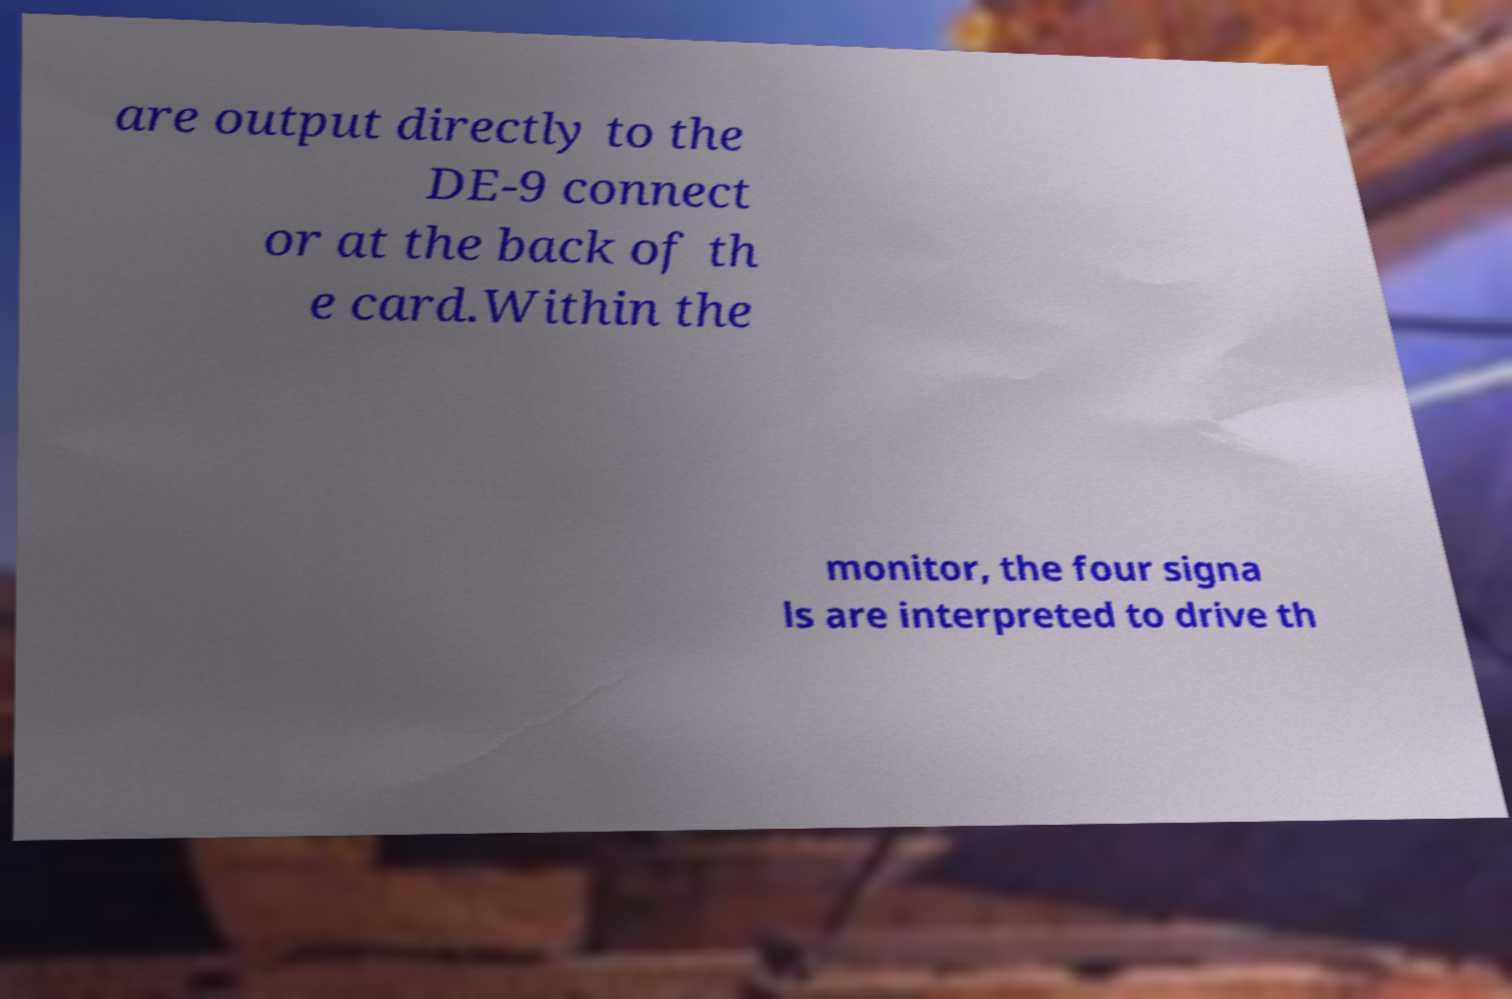Could you assist in decoding the text presented in this image and type it out clearly? are output directly to the DE-9 connect or at the back of th e card.Within the monitor, the four signa ls are interpreted to drive th 